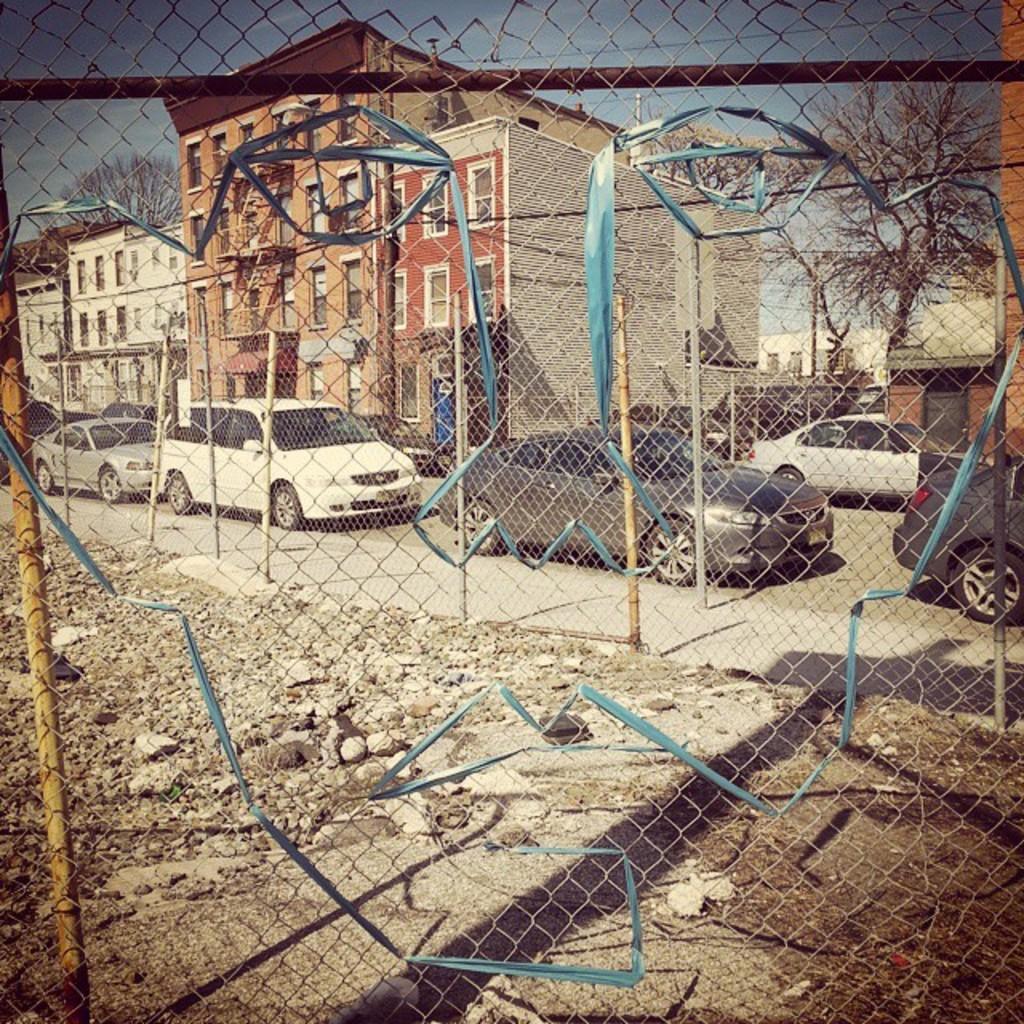Please provide a concise description of this image. In this picture we can see a fence and some vehicles on the road. Behind the vehicles there are buildings, trees and a sky. 